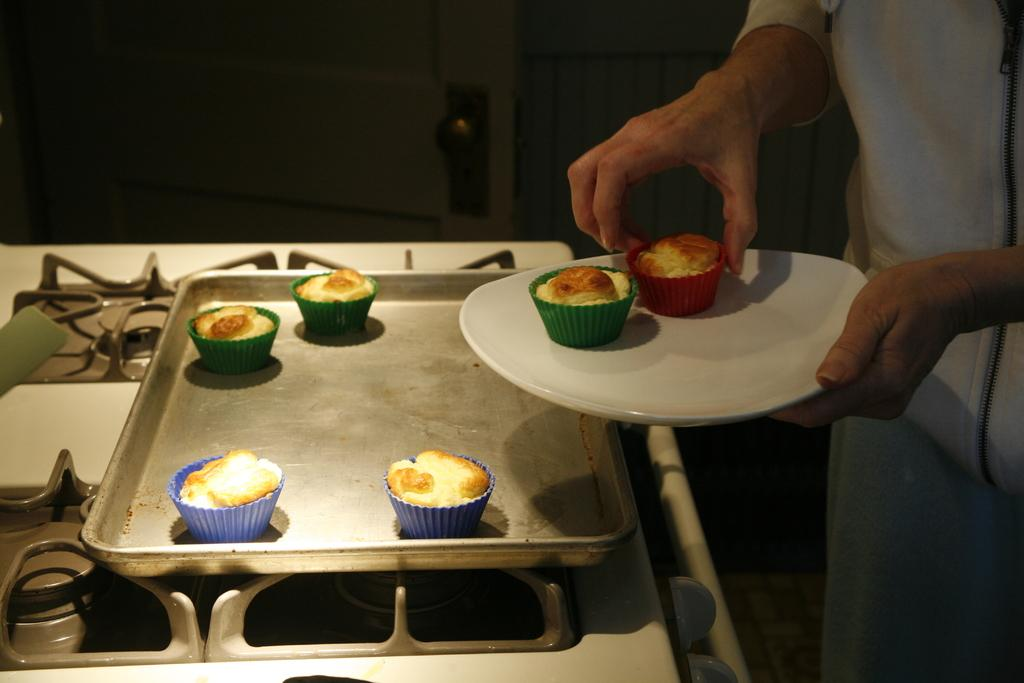What is the person holding in the image? The person is holding a cupcake and a plate. What else can be seen related to cupcakes in the image? There are cupcakes on a tray. Where is the tray with cupcakes located? The tray is on a stove. What can be observed about the lighting in the image? The background of the image is dark. What type of clouds can be seen in the image? There are no clouds visible in the image, as the background is dark and does not show any sky or outdoor elements. 